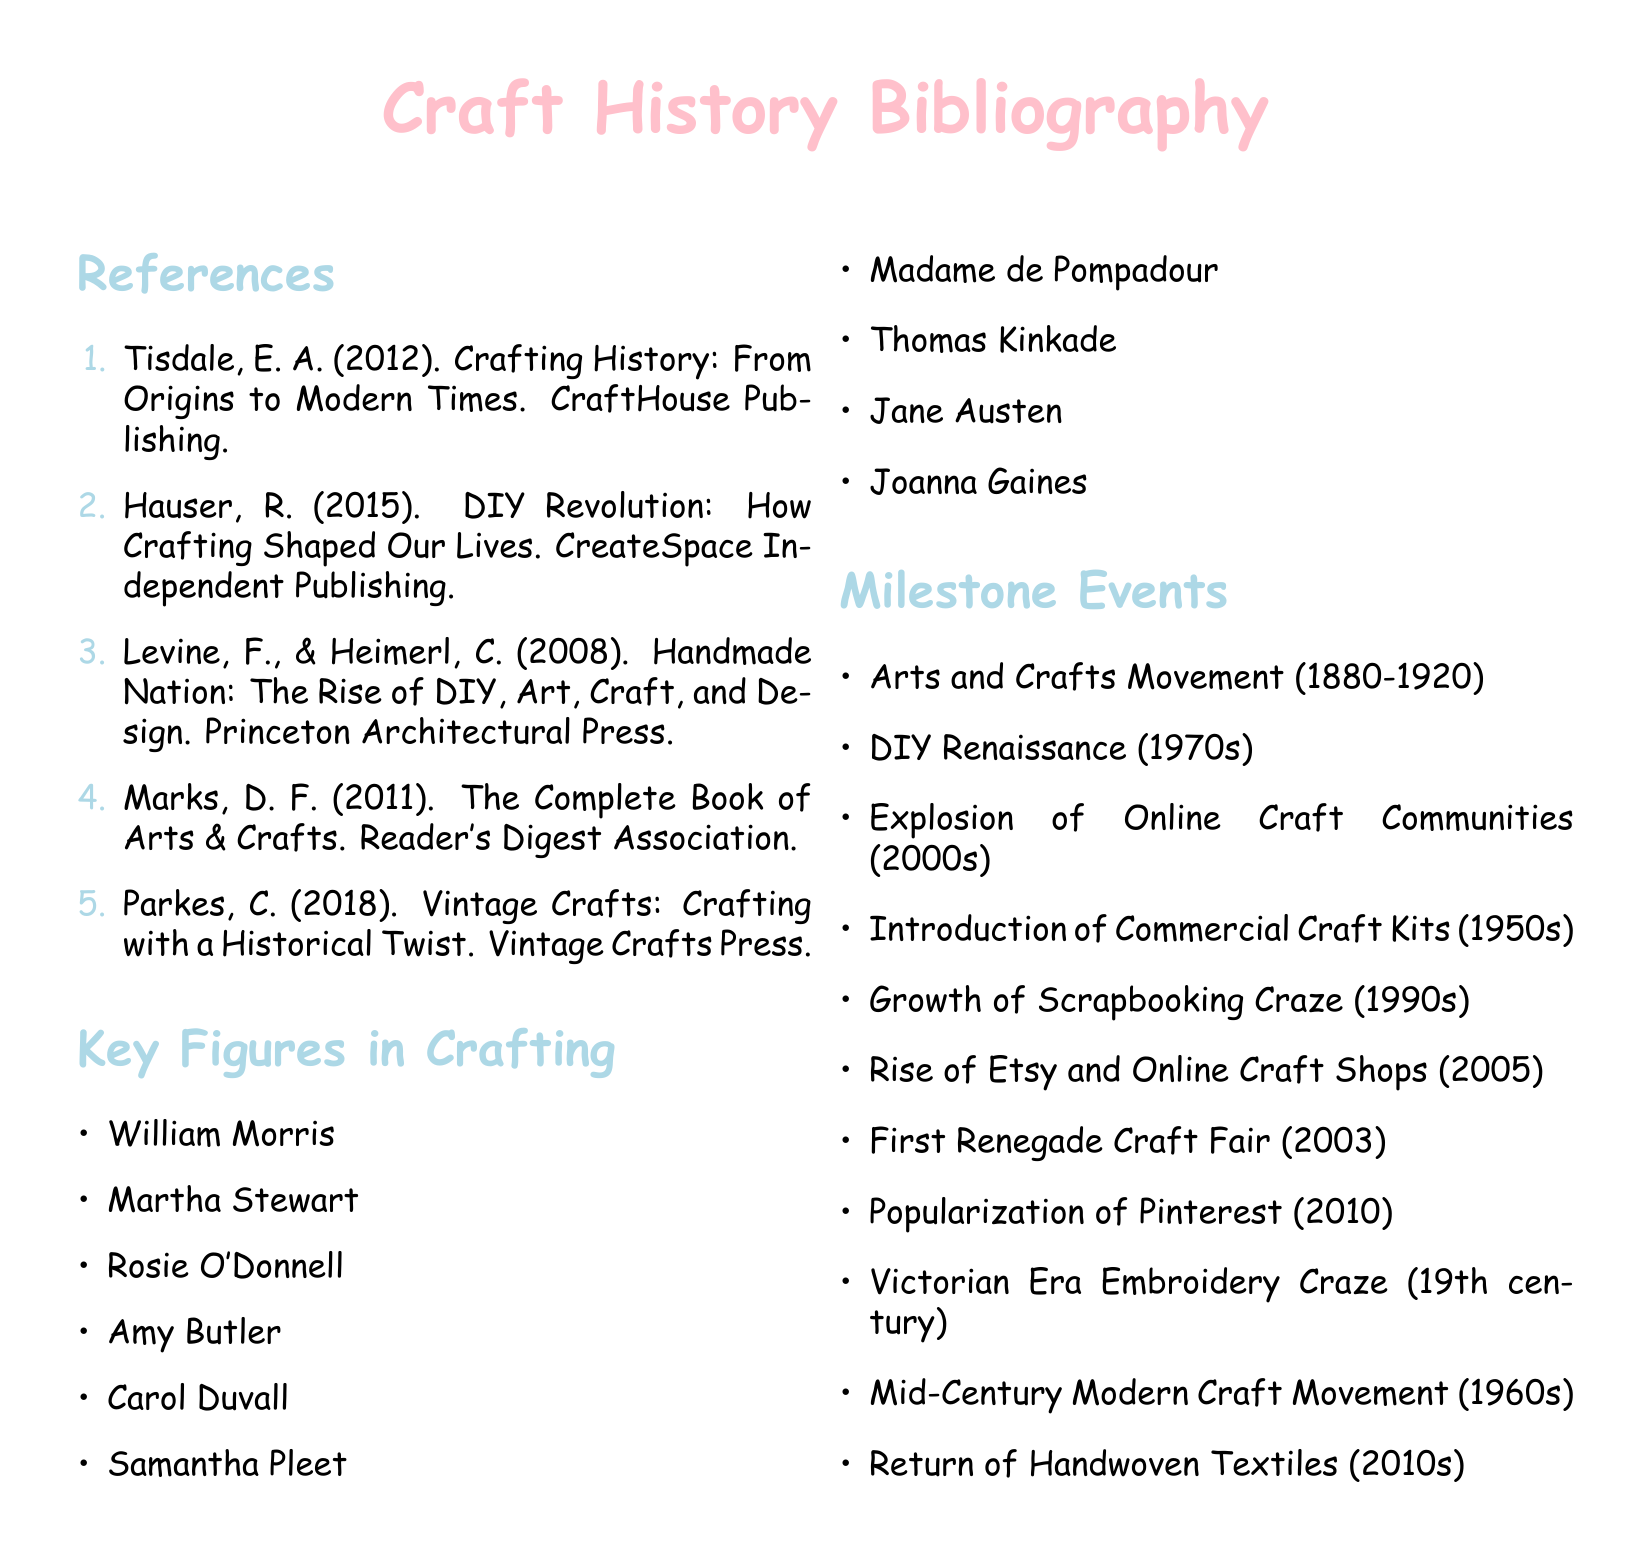What is the title of the book by Tisdale? The title is listed in the references section as the first entry.
Answer: Crafting History: From Origins to Modern Times Who is one of the key figures associated with the crafting world? The list of key figures includes names that have made significant contributions to crafting.
Answer: William Morris What year did the DIY Renaissance take place? The milestone events section specifies the time frame for this movement.
Answer: 1970s Which publication discusses the rise of DIY, art, craft, and design? This is found in the references section listing the authors and their publication.
Answer: Handmade Nation: The Rise of DIY, Art, Craft, and Design What significant event in crafting occurred in 2003? The milestone events section identifies specific events and their corresponding years.
Answer: First Renegade Craft Fair Which crafting movement took place from 1880 to 1920? This is noted in the list of milestone events, providing a historical context for crafting trends.
Answer: Arts and Crafts Movement In what year did Pinterest become popular? The year of event is noted to mark significant developments in crafting trends.
Answer: 2010 What is the name of the publisher for the book by Hauser? The publishing company is listed alongside the author's name in the references section.
Answer: CreateSpace Independent Publishing 